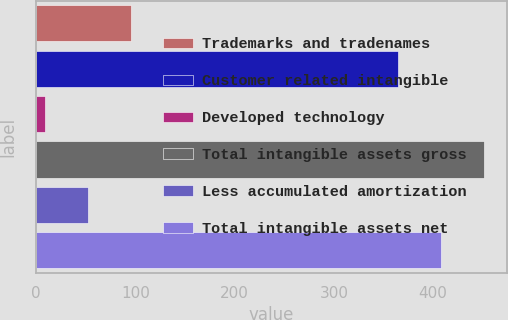<chart> <loc_0><loc_0><loc_500><loc_500><bar_chart><fcel>Trademarks and tradenames<fcel>Customer related intangible<fcel>Developed technology<fcel>Total intangible assets gross<fcel>Less accumulated amortization<fcel>Total intangible assets net<nl><fcel>95.6<fcel>365<fcel>9<fcel>451.6<fcel>52.3<fcel>408.3<nl></chart> 